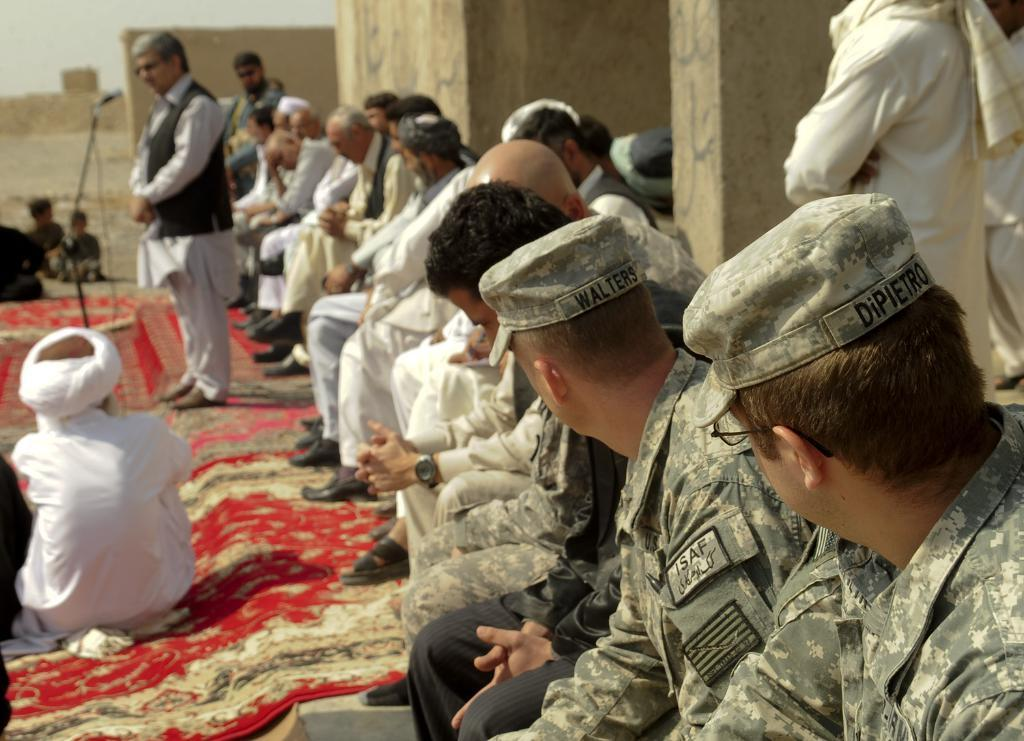What are the people in the image doing? There are people sitting and standing in the image. Can you describe the person who is standing in front of a microphone? One person is standing and talking in front of a microphone. What type of clover is being used as a prop by the person standing in front of the microphone? There is no clover present in the image, and the person standing in front of the microphone is not using any props. 